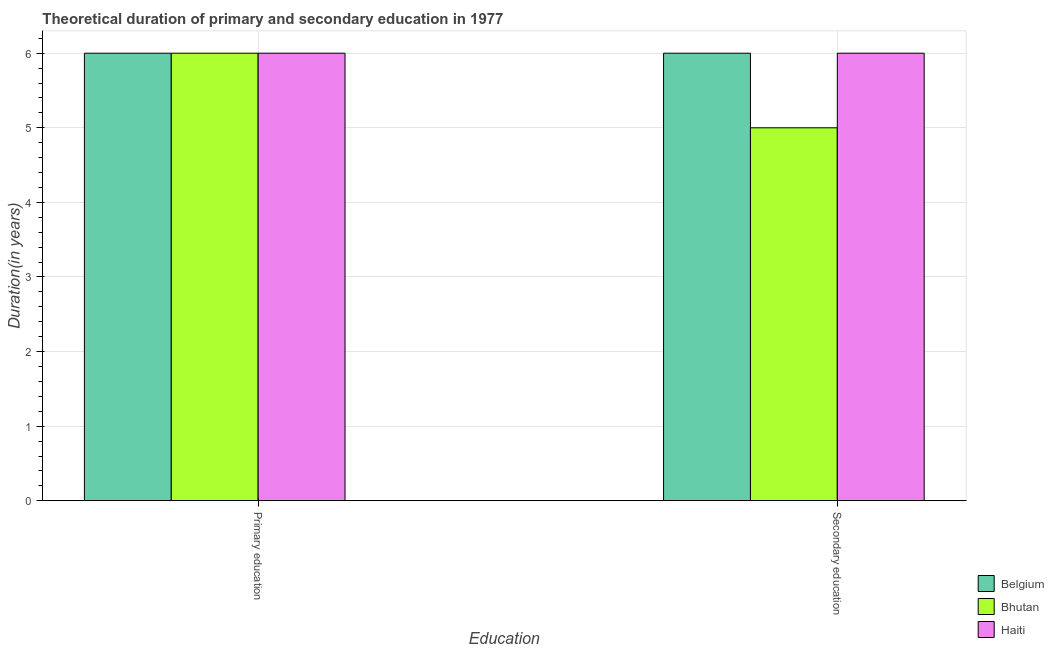How many groups of bars are there?
Make the answer very short. 2. Are the number of bars on each tick of the X-axis equal?
Provide a short and direct response. Yes. How many bars are there on the 1st tick from the left?
Offer a terse response. 3. How many bars are there on the 2nd tick from the right?
Make the answer very short. 3. What is the label of the 1st group of bars from the left?
Offer a terse response. Primary education. What is the duration of primary education in Bhutan?
Provide a short and direct response. 6. Across all countries, what is the maximum duration of primary education?
Keep it short and to the point. 6. Across all countries, what is the minimum duration of secondary education?
Provide a succinct answer. 5. In which country was the duration of secondary education minimum?
Your answer should be compact. Bhutan. What is the total duration of secondary education in the graph?
Offer a terse response. 17. What is the difference between the duration of secondary education in Bhutan and that in Haiti?
Ensure brevity in your answer.  -1. What is the difference between the duration of primary education in Haiti and the duration of secondary education in Bhutan?
Offer a terse response. 1. What is the average duration of secondary education per country?
Make the answer very short. 5.67. What is the difference between the duration of secondary education and duration of primary education in Haiti?
Offer a terse response. 0. In how many countries, is the duration of secondary education greater than 4 years?
Offer a terse response. 3. What is the ratio of the duration of primary education in Haiti to that in Belgium?
Give a very brief answer. 1. In how many countries, is the duration of secondary education greater than the average duration of secondary education taken over all countries?
Ensure brevity in your answer.  2. What does the 2nd bar from the left in Secondary education represents?
Give a very brief answer. Bhutan. How many countries are there in the graph?
Offer a terse response. 3. Does the graph contain any zero values?
Give a very brief answer. No. Where does the legend appear in the graph?
Make the answer very short. Bottom right. How are the legend labels stacked?
Your response must be concise. Vertical. What is the title of the graph?
Give a very brief answer. Theoretical duration of primary and secondary education in 1977. What is the label or title of the X-axis?
Offer a very short reply. Education. What is the label or title of the Y-axis?
Provide a succinct answer. Duration(in years). What is the Duration(in years) in Haiti in Primary education?
Your answer should be compact. 6. What is the Duration(in years) of Haiti in Secondary education?
Your answer should be compact. 6. Across all Education, what is the maximum Duration(in years) of Belgium?
Keep it short and to the point. 6. Across all Education, what is the maximum Duration(in years) in Bhutan?
Keep it short and to the point. 6. Across all Education, what is the maximum Duration(in years) of Haiti?
Offer a very short reply. 6. Across all Education, what is the minimum Duration(in years) of Belgium?
Offer a very short reply. 6. Across all Education, what is the minimum Duration(in years) in Bhutan?
Make the answer very short. 5. What is the total Duration(in years) of Bhutan in the graph?
Your response must be concise. 11. What is the difference between the Duration(in years) in Belgium in Primary education and that in Secondary education?
Give a very brief answer. 0. What is the difference between the Duration(in years) in Belgium in Primary education and the Duration(in years) in Bhutan in Secondary education?
Offer a terse response. 1. What is the difference between the Duration(in years) of Bhutan in Primary education and the Duration(in years) of Haiti in Secondary education?
Your response must be concise. 0. What is the average Duration(in years) in Bhutan per Education?
Your answer should be very brief. 5.5. What is the difference between the Duration(in years) in Bhutan and Duration(in years) in Haiti in Primary education?
Your answer should be compact. 0. What is the difference between the Duration(in years) of Belgium and Duration(in years) of Haiti in Secondary education?
Ensure brevity in your answer.  0. What is the ratio of the Duration(in years) in Belgium in Primary education to that in Secondary education?
Your response must be concise. 1. What is the difference between the highest and the second highest Duration(in years) in Bhutan?
Ensure brevity in your answer.  1. What is the difference between the highest and the lowest Duration(in years) in Belgium?
Offer a terse response. 0. What is the difference between the highest and the lowest Duration(in years) of Bhutan?
Keep it short and to the point. 1. What is the difference between the highest and the lowest Duration(in years) of Haiti?
Offer a very short reply. 0. 